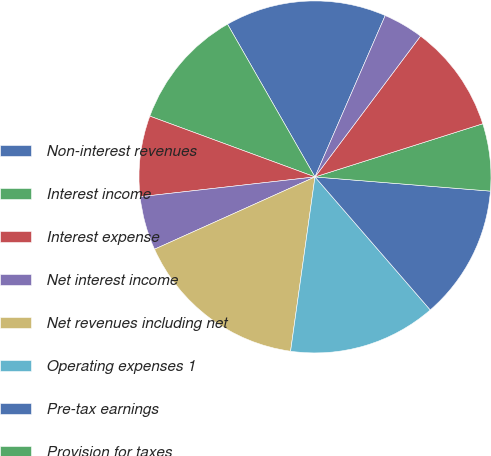<chart> <loc_0><loc_0><loc_500><loc_500><pie_chart><fcel>Non-interest revenues<fcel>Interest income<fcel>Interest expense<fcel>Net interest income<fcel>Net revenues including net<fcel>Operating expenses 1<fcel>Pre-tax earnings<fcel>Provision for taxes<fcel>Net earnings<fcel>Preferred stock dividends<nl><fcel>14.81%<fcel>11.11%<fcel>7.41%<fcel>4.94%<fcel>16.05%<fcel>13.58%<fcel>12.35%<fcel>6.17%<fcel>9.88%<fcel>3.7%<nl></chart> 